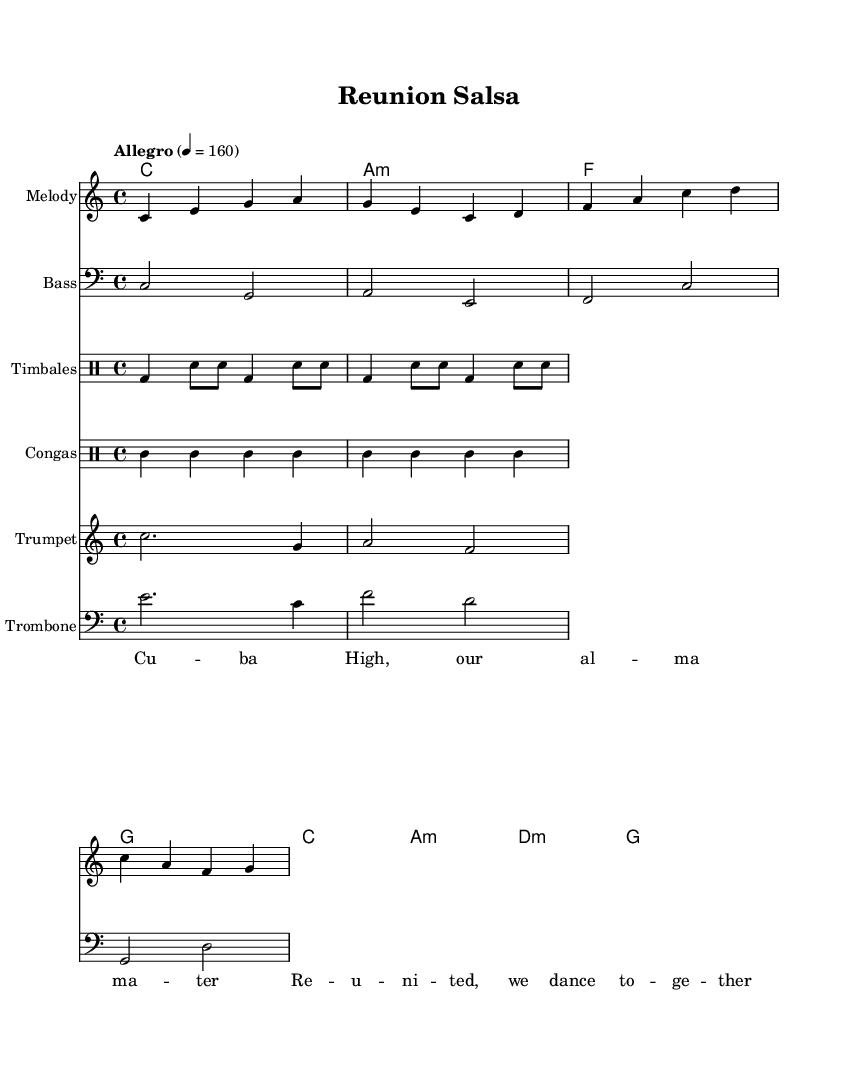What is the key signature of this music? The key signature shown in the global context at the beginning is C major, which indicates that there are no sharps or flats.
Answer: C major What is the time signature of this piece? The time signature is indicated at the beginning of the global section as 4/4, meaning there are four beats in a measure and a quarter note gets one beat.
Answer: 4/4 What is the tempo marking for this music? The tempo marking is found in the global section, stating "Allegro" and a corresponding metronome marking of 160 beats per minute, indicating a fast pace.
Answer: Allegro, 160 Which instruments are featured in this arrangement? The arrangement includes various instruments as evident from the score; they are Melody, Bass, Timbales, Congas, Trumpet, and Trombone.
Answer: Melody, Bass, Timbales, Congas, Trumpet, Trombone How many measures are there in the melody? By closely counting the measures in the melody section, there are a total of 4 measures shown in the provided music.
Answer: 4 What genres do timbales and congas belong to in Latin music? Timbales and congas are recognized as percussion instruments that are essential for rhythm in Latin music genres, specifically in Salsa and other styles.
Answer: Salsa What are the lyrics referencing in this piece? The lyrics reference Cuba High and the experience of a reunion, celebrating together through dance as indicated by the text provided in the lyrics section.
Answer: Cuba High, our alma mater 